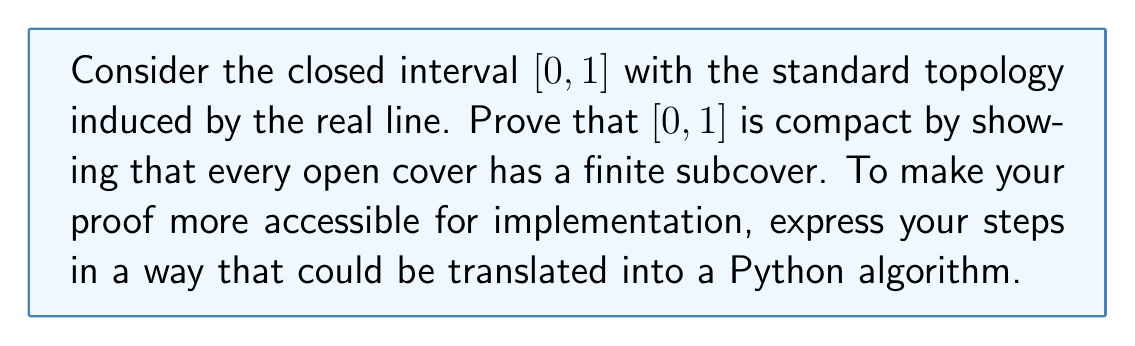Show me your answer to this math problem. To prove that $[0,1]$ is compact, we need to show that every open cover has a finite subcover. Let's approach this step-by-step:

1) Let $\mathcal{U} = \{U_\alpha\}_{\alpha \in A}$ be an arbitrary open cover of $[0,1]$.

2) We will construct a finite subcover using the following algorithm:

   a) Initialize two sets: $S = \emptyset$ (for the subcover) and $I = [0,1]$ (the interval to cover).
   
   b) While $I$ is not empty:
      - Find the smallest $x \in I$ such that $x$ is not covered by $S$.
      - Find a $U_\alpha \in \mathcal{U}$ that contains $x$.
      - Add $U_\alpha$ to $S$.
      - Update $I$ by removing the portion covered by $U_\alpha$.

3) To implement this in Python-like pseudocode:

```python
S = []
I = [0, 1]
while I:
    x = min(I)
    U = find_open_set_containing(x, open_cover)
    S.append(U)
    I = update_interval(I, U)
```

4) This algorithm terminates because:
   - In each iteration, we remove a non-empty open subset from $I$.
   - $[0,1]$ has the least upper bound property (Dedekind completeness).
   - Therefore, after finitely many steps, $I$ will become empty.

5) When the algorithm terminates, $S$ is a finite subcover of $[0,1]$.

6) The key topological properties we used:
   - Every open subset of $\mathbb{R}$ is a union of open intervals.
   - $[0,1]$ is connected and has the least upper bound property.

This proof demonstrates that every open cover of $[0,1]$ has a finite subcover, thus proving that $[0,1]$ is compact.
Answer: $[0,1]$ is compact. A finite subcover can always be constructed from any open cover using the algorithm described, which terminates in finitely many steps due to the least upper bound property of $[0,1]$. 